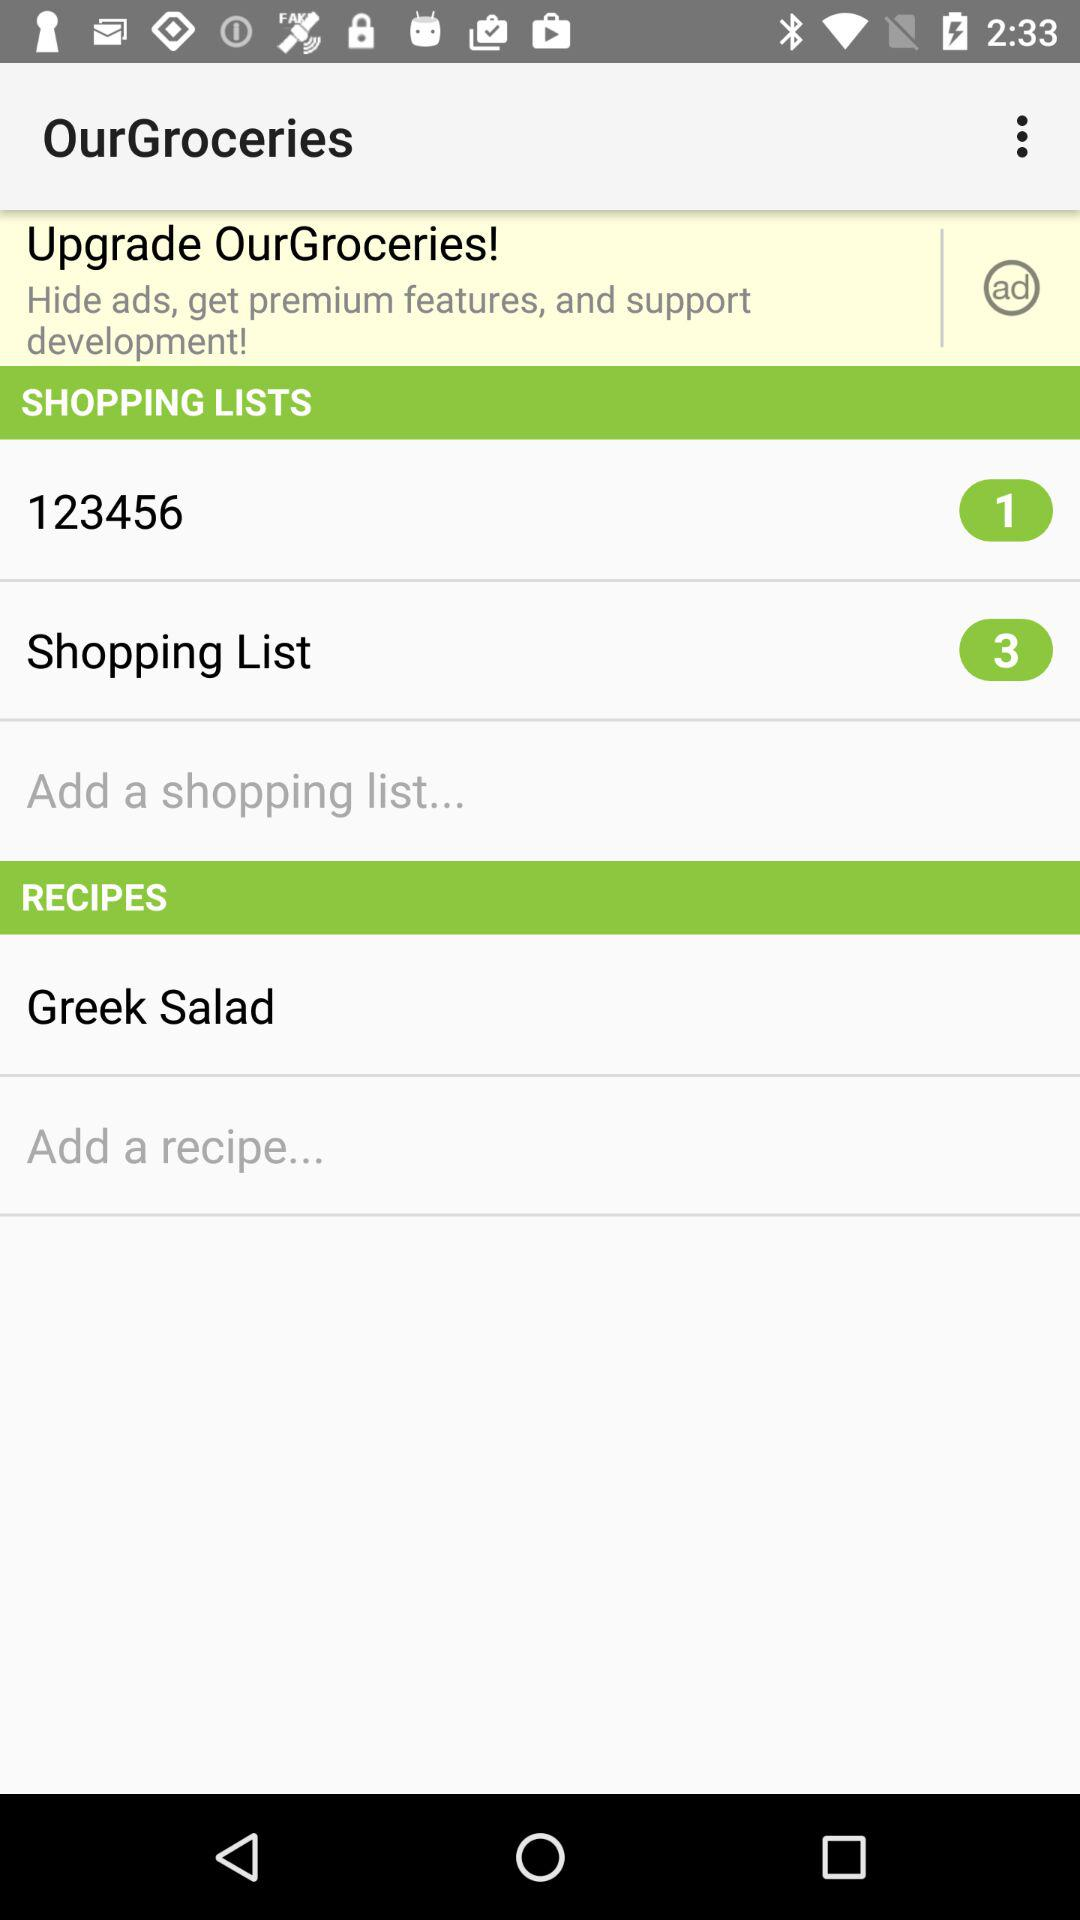What is the name of the shopping list that has one item? The name of the shopping list that has one item is "123456". 